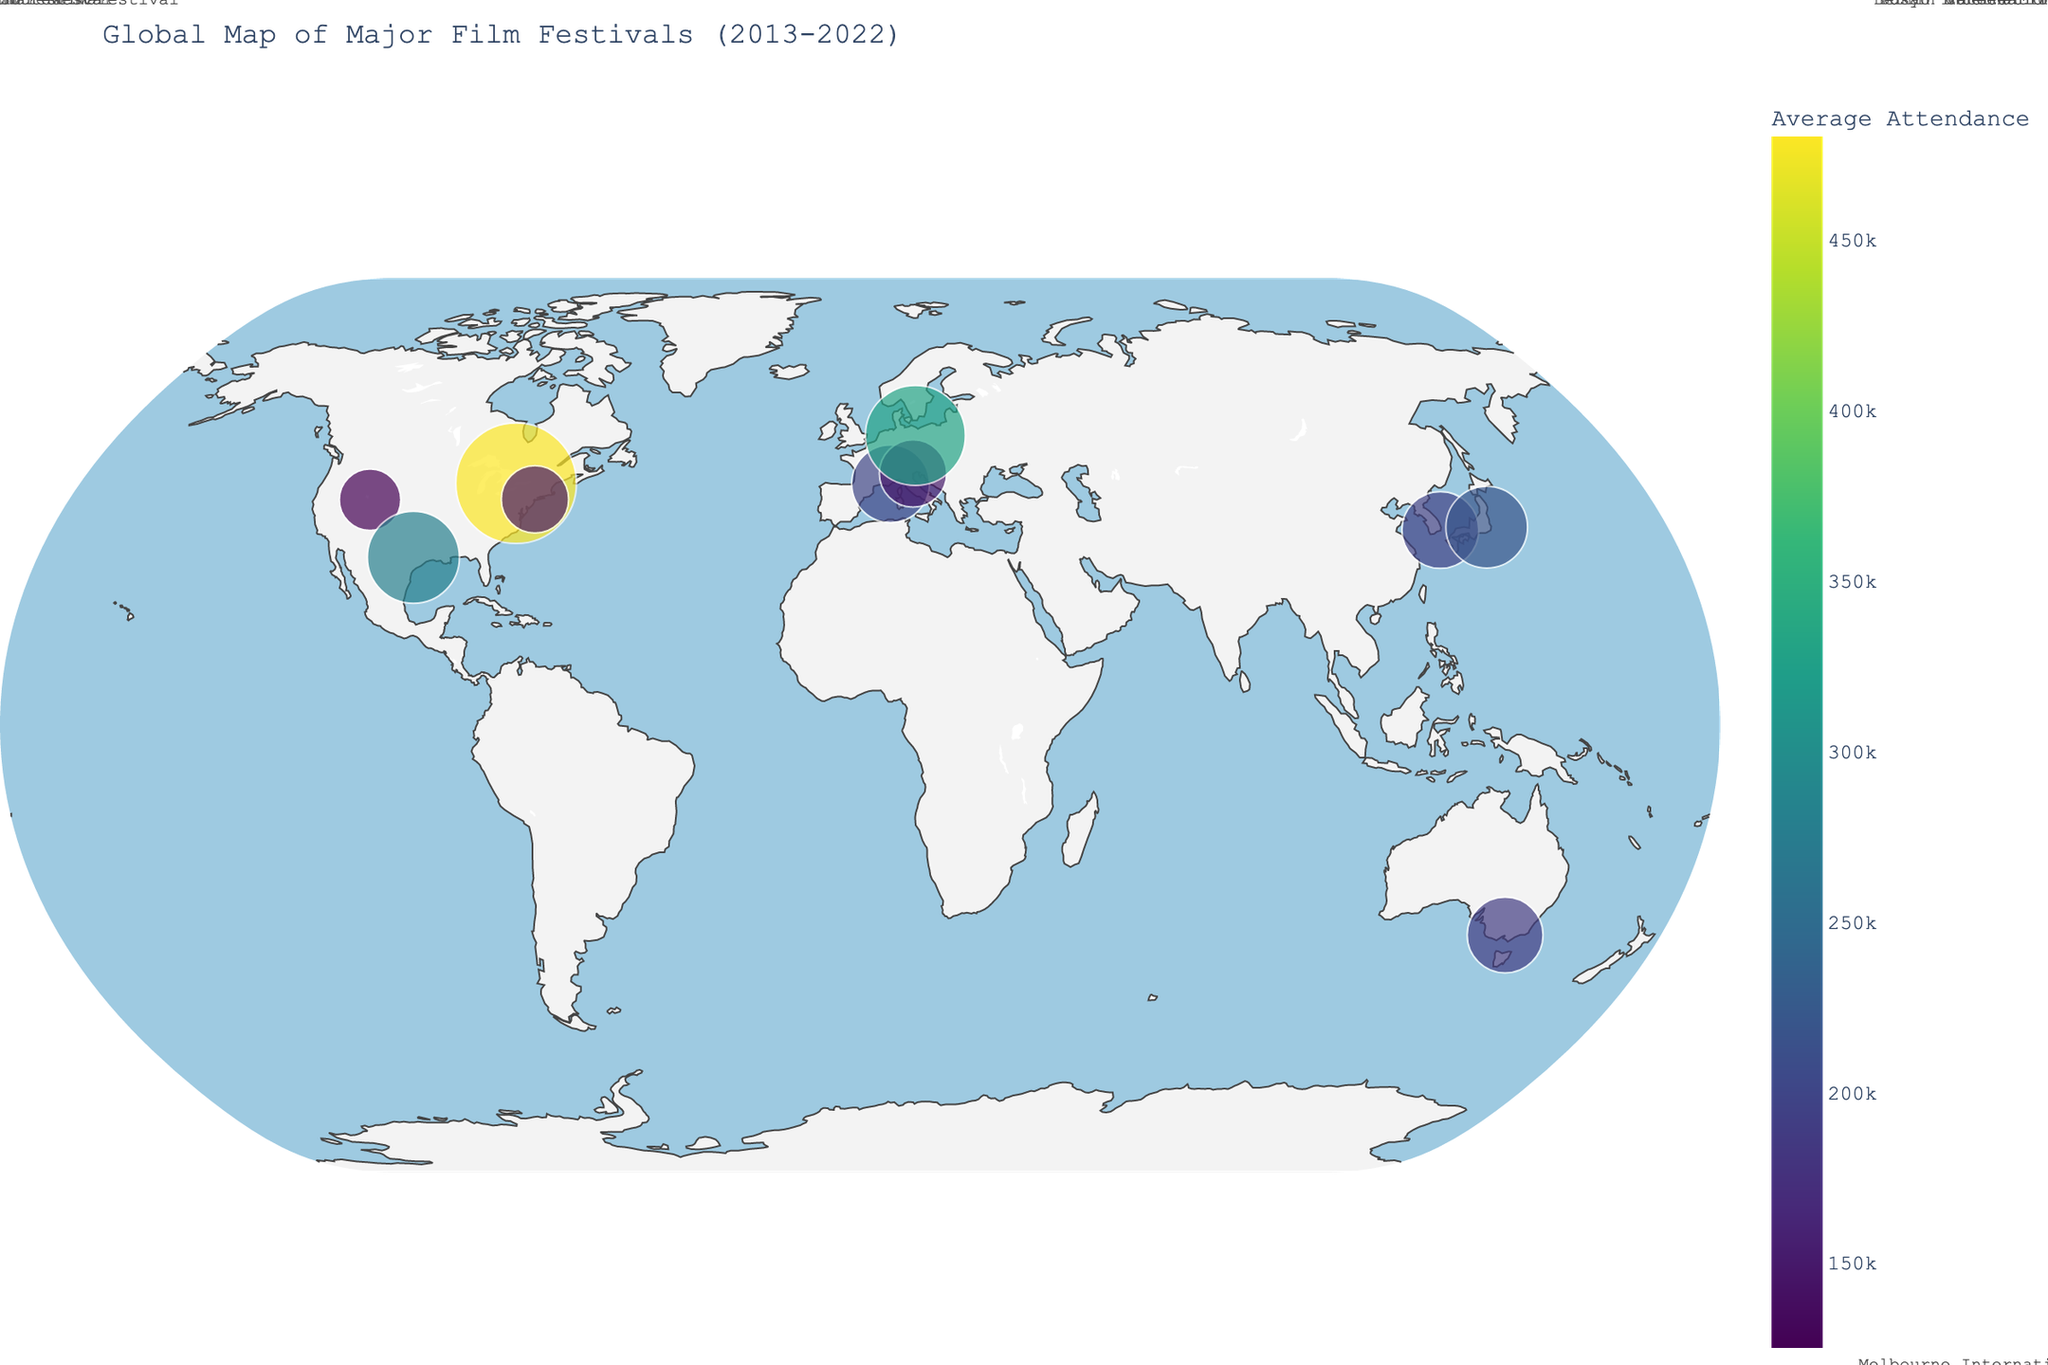What's the title of the figure? The title is usually found at the top of the figure and summarizes the content. Here, the title is "Global Map of Major Film Festivals (2013-2022)"
Answer: Global Map of Major Film Festivals (2013-2022) Which festival has the highest average attendance? By looking for the largest circle on the map and analyzing the color scale, we can identify the Toronto International Film Festival as having the highest attendance rate of 480,000.
Answer: Toronto International Film Festival What geographic region has the most film festivals represented on this map? By visually inspecting the map, the region with the highest density of film festival markers is North America, with several festivals in the USA and Canada.
Answer: North America What is the average attendance of the Cannes Film Festival? Locate Cannes on the map (in the south of France) and read the figure's data on average attendance, which is 200,000.
Answer: 200,000 Which film festival has the lowest average attendance? By identifying the smallest circle on the map and checking the color scale, we find that Sundance Film Festival has the lowest average attendance of 125,000.
Answer: Sundance Film Festival Compare the attendance between the Venice Film Festival and the Berlin International Film Festival. Locate both festivals on the map. Venice has an average attendance of 150,000, whereas Berlin has an average attendance of 330,000. Berlin has a higher attendance.
Answer: Berlin International Film Festival has a higher attendance What is the combined average attendance of the two Japanese and South Korean festivals? Look at the Busan International Film Festival and the Tokyo International Film Festival. Busan has 195,000 and Tokyo has 220,000. Their combined average attendance is 195,000 + 220,000 = 415,000.
Answer: 415,000 Which continent has only one represented festival on the map? Inspect the spatial distribution of the markers. Australia is the only continent with a single film festival, the Melbourne International Film Festival.
Answer: Australia What is the color scheme used for representing average attendance? By observing the color gradients on the map and the color bar, we see it uses the Viridis color scale, where darker shades represent lower attendance and brighter shades represent higher attendance.
Answer: Viridis Out of the film festivals represented, which city hosts both the festival with the highest and the lowest attendance? Locate the cities with their corresponding attendance: Toronto (highest) and Park City (lowest). No city hosts both. The statement in the question is invalid here.
Answer: None 